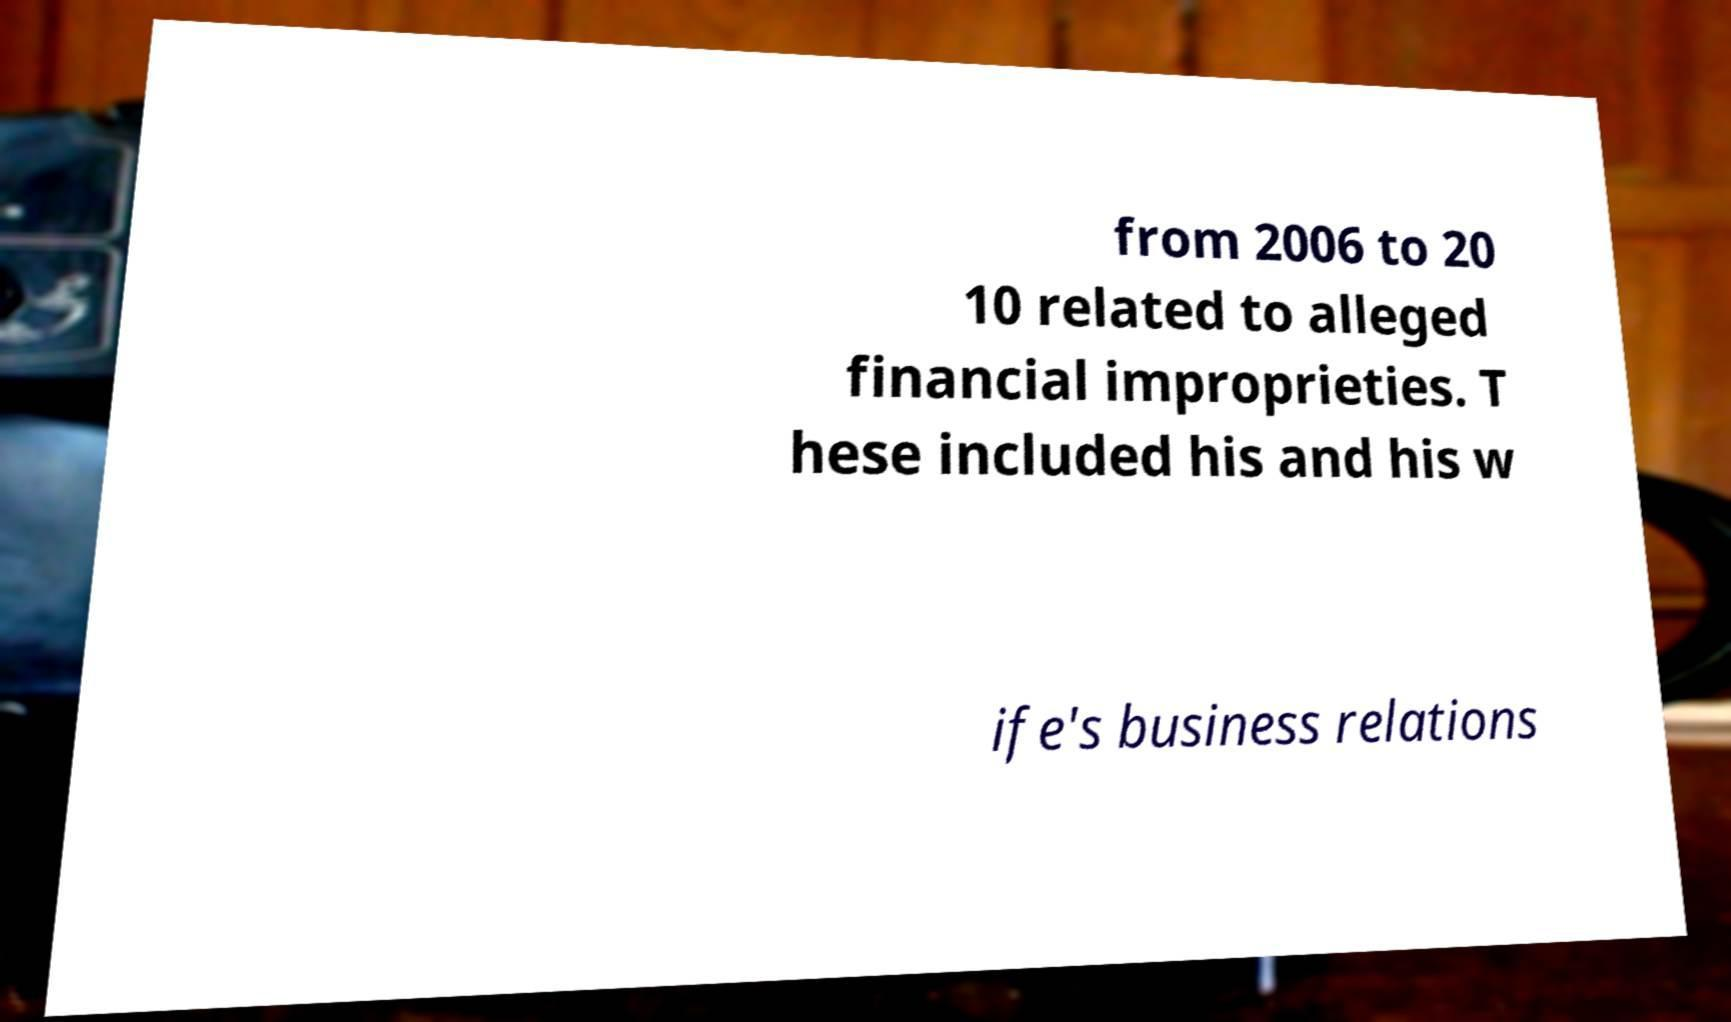There's text embedded in this image that I need extracted. Can you transcribe it verbatim? from 2006 to 20 10 related to alleged financial improprieties. T hese included his and his w ife's business relations 